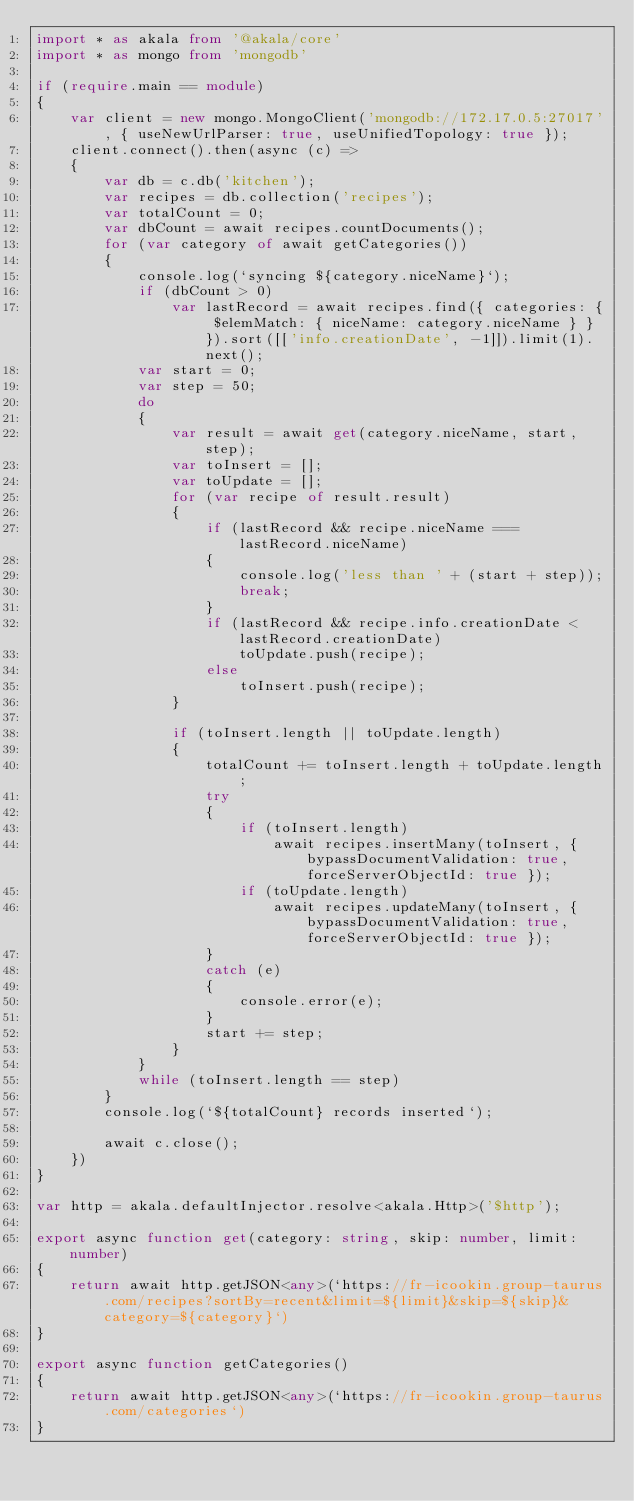Convert code to text. <code><loc_0><loc_0><loc_500><loc_500><_TypeScript_>import * as akala from '@akala/core'
import * as mongo from 'mongodb'

if (require.main == module)
{
    var client = new mongo.MongoClient('mongodb://172.17.0.5:27017', { useNewUrlParser: true, useUnifiedTopology: true });
    client.connect().then(async (c) =>
    {
        var db = c.db('kitchen');
        var recipes = db.collection('recipes');
        var totalCount = 0;
        var dbCount = await recipes.countDocuments();
        for (var category of await getCategories())
        {
            console.log(`syncing ${category.niceName}`);
            if (dbCount > 0)
                var lastRecord = await recipes.find({ categories: { $elemMatch: { niceName: category.niceName } } }).sort([['info.creationDate', -1]]).limit(1).next();
            var start = 0;
            var step = 50;
            do
            {
                var result = await get(category.niceName, start, step);
                var toInsert = [];
                var toUpdate = [];
                for (var recipe of result.result)
                {
                    if (lastRecord && recipe.niceName === lastRecord.niceName)
                    {
                        console.log('less than ' + (start + step));
                        break;
                    }
                    if (lastRecord && recipe.info.creationDate < lastRecord.creationDate)
                        toUpdate.push(recipe);
                    else
                        toInsert.push(recipe);
                }

                if (toInsert.length || toUpdate.length)
                {
                    totalCount += toInsert.length + toUpdate.length;
                    try
                    {
                        if (toInsert.length)
                            await recipes.insertMany(toInsert, { bypassDocumentValidation: true, forceServerObjectId: true });
                        if (toUpdate.length)
                            await recipes.updateMany(toInsert, { bypassDocumentValidation: true, forceServerObjectId: true });
                    }
                    catch (e)
                    {
                        console.error(e);
                    }
                    start += step;
                }
            }
            while (toInsert.length == step)
        }
        console.log(`${totalCount} records inserted`);

        await c.close();
    })
}

var http = akala.defaultInjector.resolve<akala.Http>('$http');

export async function get(category: string, skip: number, limit: number)
{
    return await http.getJSON<any>(`https://fr-icookin.group-taurus.com/recipes?sortBy=recent&limit=${limit}&skip=${skip}&category=${category}`)
}

export async function getCategories()
{
    return await http.getJSON<any>(`https://fr-icookin.group-taurus.com/categories`)
}</code> 